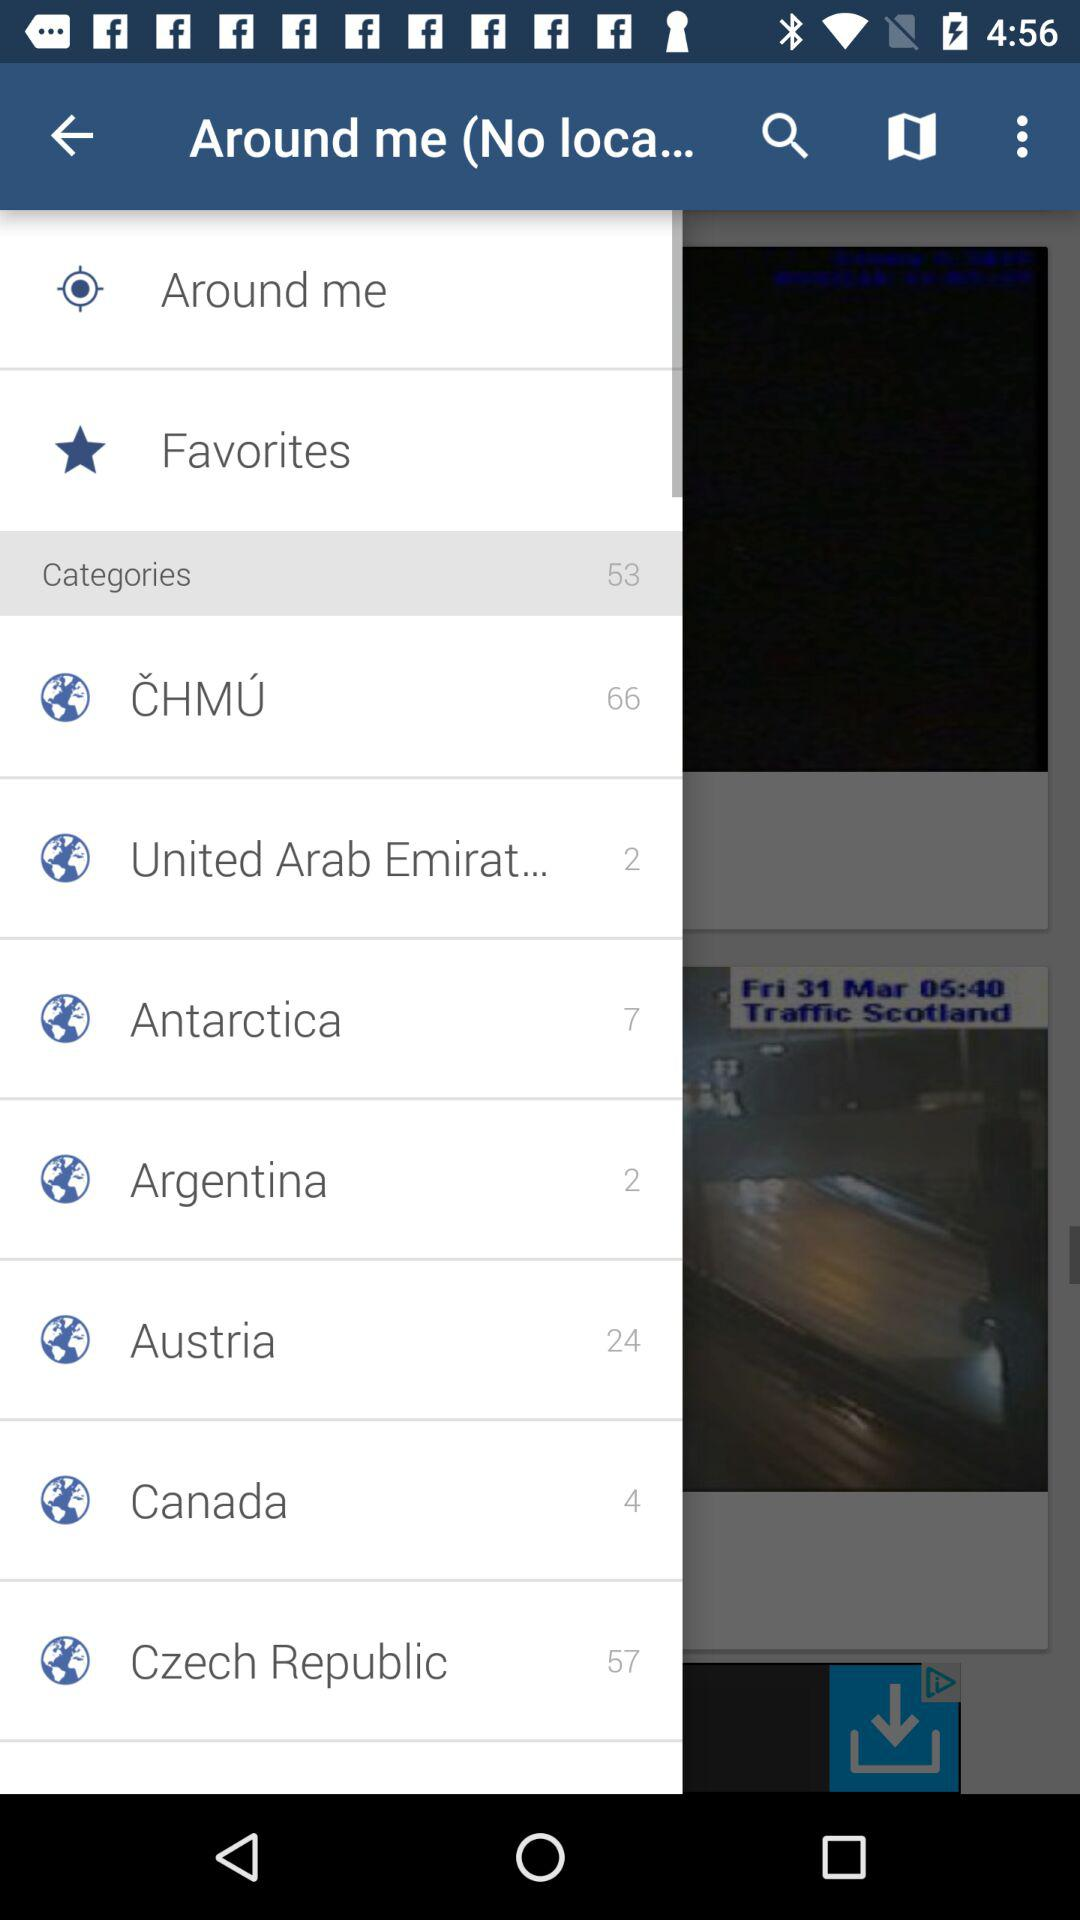How many categories are there in Antarctica? There are 7 categories. 